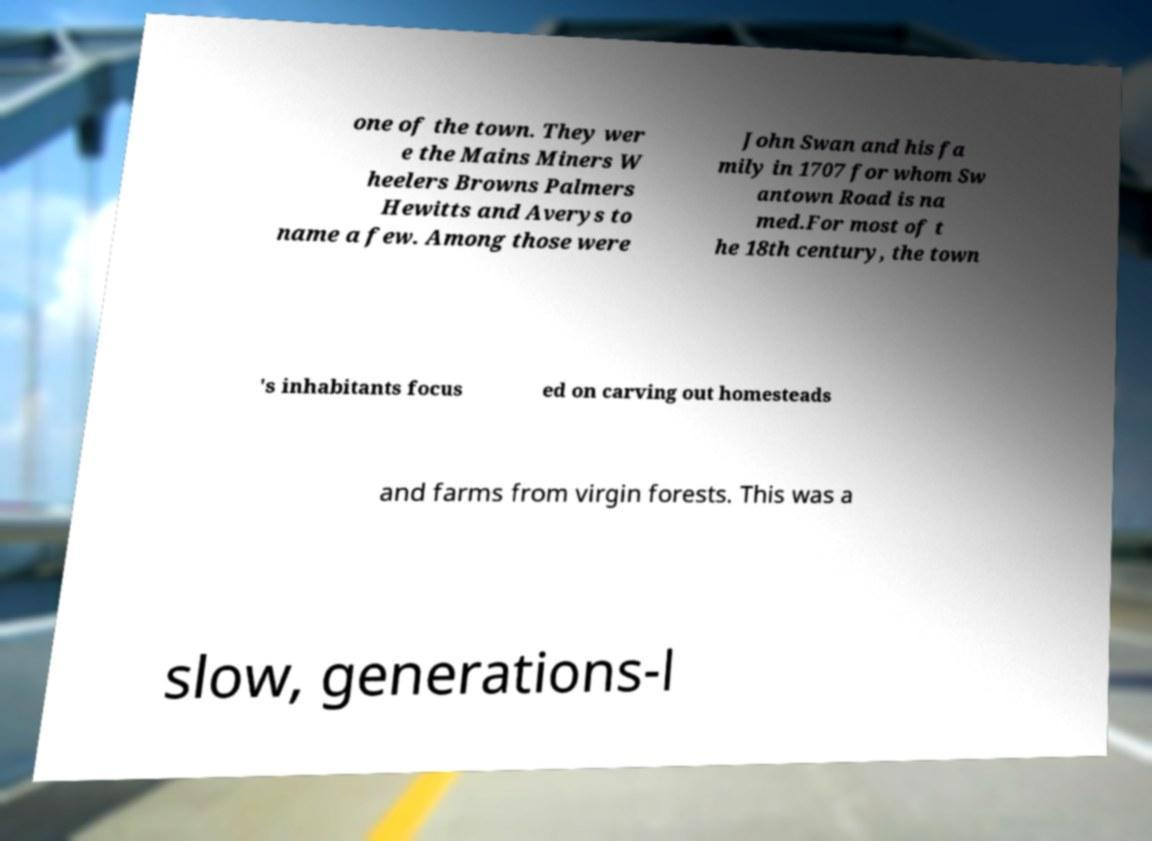I need the written content from this picture converted into text. Can you do that? one of the town. They wer e the Mains Miners W heelers Browns Palmers Hewitts and Averys to name a few. Among those were John Swan and his fa mily in 1707 for whom Sw antown Road is na med.For most of t he 18th century, the town 's inhabitants focus ed on carving out homesteads and farms from virgin forests. This was a slow, generations-l 